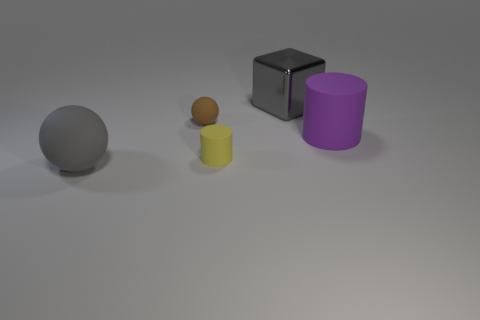There is a purple matte object in front of the matte ball that is behind the cylinder that is to the right of the gray block; how big is it?
Give a very brief answer. Large. How many tiny brown things are behind the big gray cube behind the brown matte sphere?
Provide a short and direct response. 0. What is the size of the object that is on the right side of the small brown object and on the left side of the large gray metallic cube?
Make the answer very short. Small. What number of metallic objects are either tiny gray blocks or balls?
Provide a short and direct response. 0. What is the material of the brown sphere?
Your answer should be very brief. Rubber. There is a large gray object that is to the left of the big gray thing that is behind the large gray thing left of the big gray block; what is it made of?
Provide a short and direct response. Rubber. What shape is the gray metallic object that is the same size as the purple matte object?
Ensure brevity in your answer.  Cube. How many things are red metal cubes or cylinders that are left of the big gray metallic thing?
Make the answer very short. 1. Is the large gray thing that is on the right side of the small brown matte object made of the same material as the gray object to the left of the tiny brown object?
Make the answer very short. No. What is the shape of the thing that is the same color as the cube?
Offer a very short reply. Sphere. 